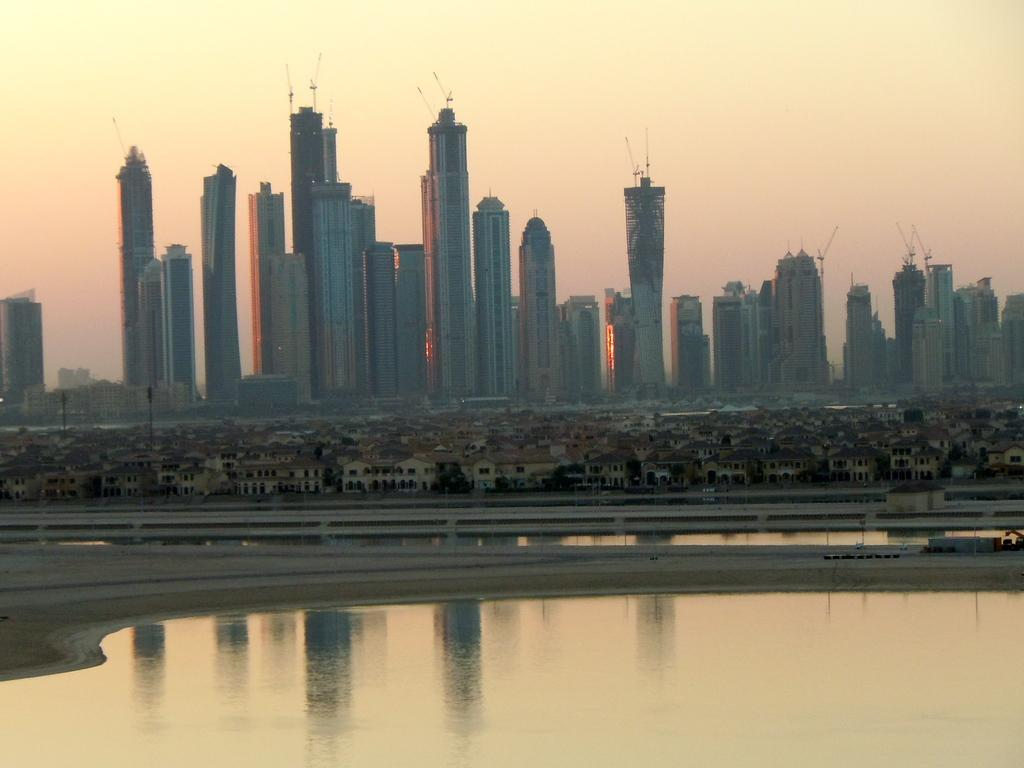What type of environment is depicted in the image? The image shows a combination of water, ground, and buildings. Can you describe the natural elements in the image? Water and ground are the natural elements visible in the image. What is visible in the background of the image? The sky is visible in the background of the image. How many types of structures can be seen in the image? There are buildings visible in the image. What type of songs can be heard playing in the background of the image? There is no audio or music present in the image, so it is not possible to determine what songs might be heard. 